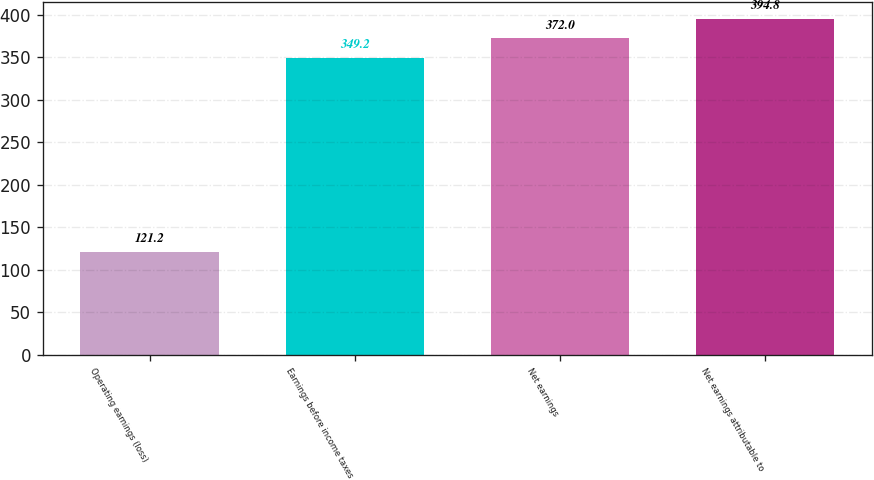Convert chart. <chart><loc_0><loc_0><loc_500><loc_500><bar_chart><fcel>Operating earnings (loss)<fcel>Earnings before income taxes<fcel>Net earnings<fcel>Net earnings attributable to<nl><fcel>121.2<fcel>349.2<fcel>372<fcel>394.8<nl></chart> 